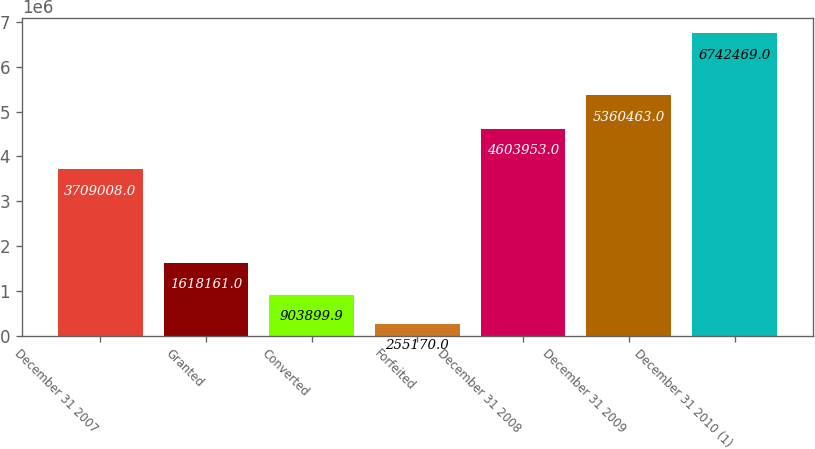Convert chart. <chart><loc_0><loc_0><loc_500><loc_500><bar_chart><fcel>December 31 2007<fcel>Granted<fcel>Converted<fcel>Forfeited<fcel>December 31 2008<fcel>December 31 2009<fcel>December 31 2010 (1)<nl><fcel>3.70901e+06<fcel>1.61816e+06<fcel>903900<fcel>255170<fcel>4.60395e+06<fcel>5.36046e+06<fcel>6.74247e+06<nl></chart> 